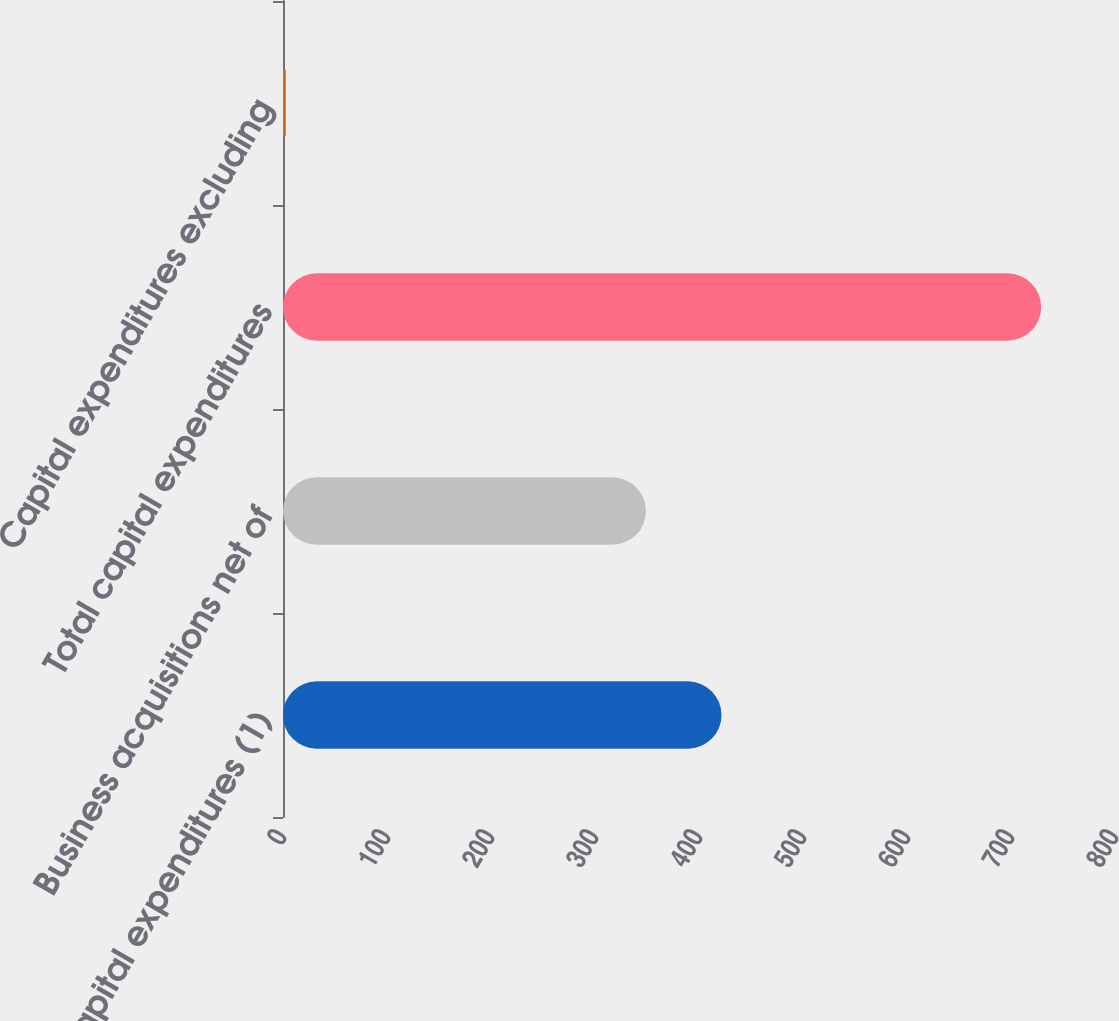Convert chart to OTSL. <chart><loc_0><loc_0><loc_500><loc_500><bar_chart><fcel>Capital expenditures (1)<fcel>Business acquisitions net of<fcel>Total capital expenditures<fcel>Capital expenditures excluding<nl><fcel>421.63<fcel>349<fcel>729<fcel>2.7<nl></chart> 